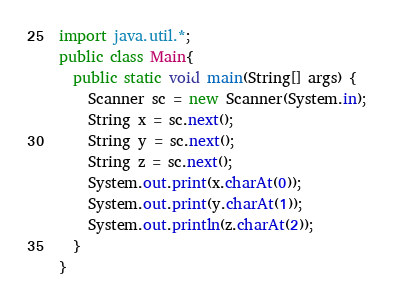<code> <loc_0><loc_0><loc_500><loc_500><_Java_>import java.util.*;
public class Main{
  public static void main(String[] args) {
    Scanner sc = new Scanner(System.in);
    String x = sc.next();
    String y = sc.next();
    String z = sc.next();
    System.out.print(x.charAt(0));
    System.out.print(y.charAt(1));
    System.out.println(z.charAt(2));
  }
}
</code> 